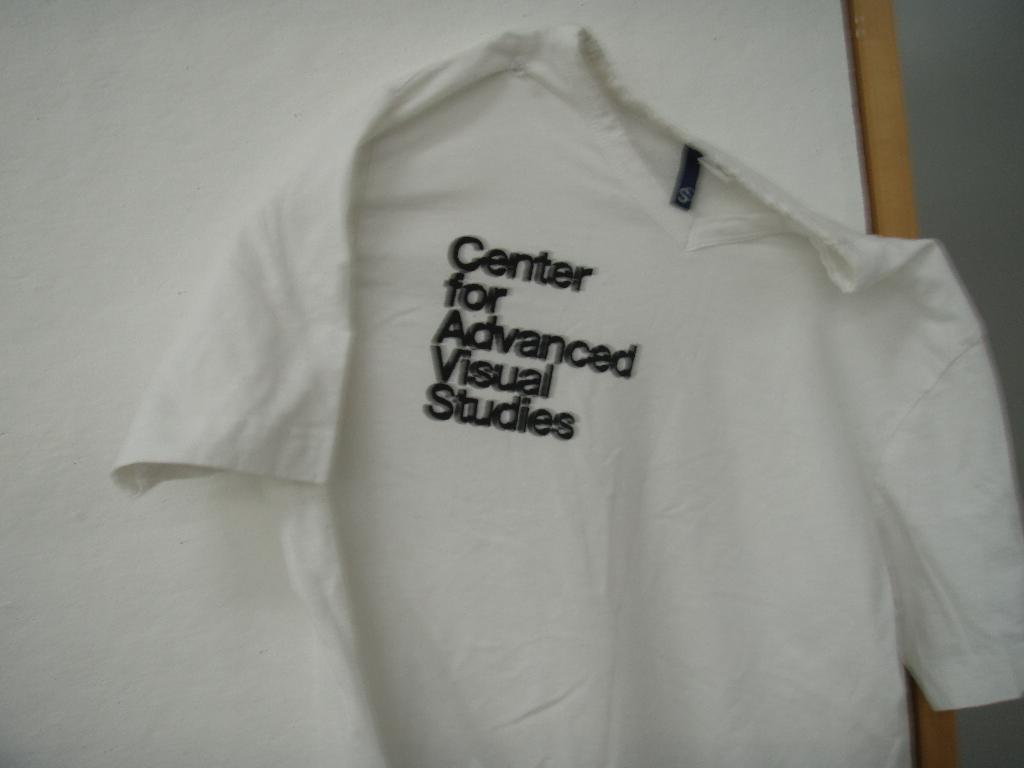<image>
Create a compact narrative representing the image presented. A white tshirt with the words Center for Advanced Visual Studies written on it. 